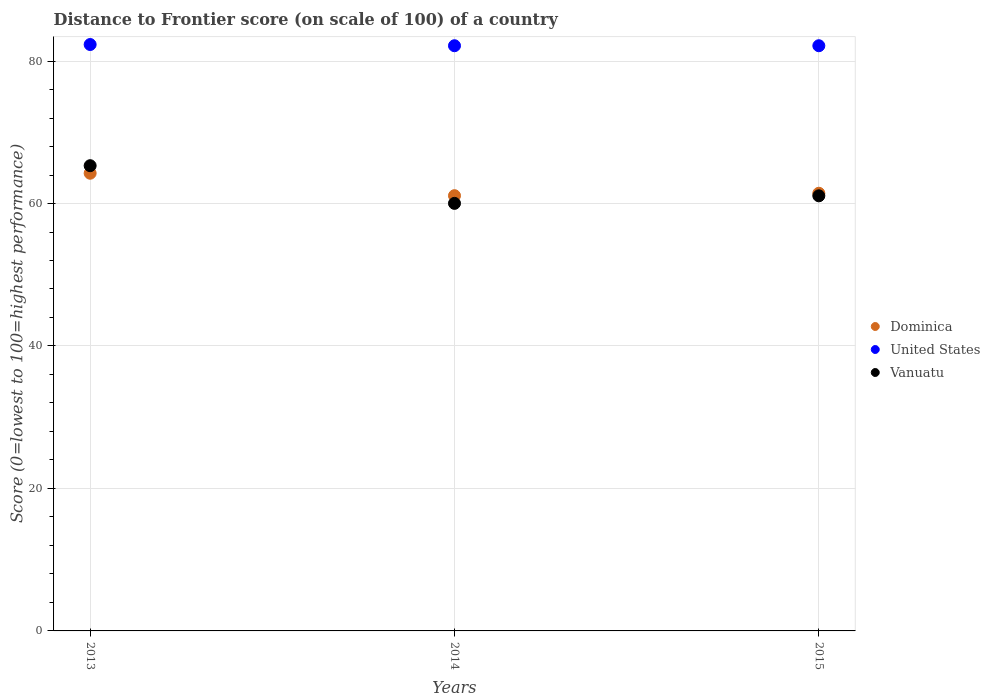How many different coloured dotlines are there?
Ensure brevity in your answer.  3. Is the number of dotlines equal to the number of legend labels?
Offer a very short reply. Yes. What is the distance to frontier score of in United States in 2015?
Provide a succinct answer. 82.15. Across all years, what is the maximum distance to frontier score of in Vanuatu?
Ensure brevity in your answer.  65.31. Across all years, what is the minimum distance to frontier score of in United States?
Offer a terse response. 82.15. In which year was the distance to frontier score of in United States minimum?
Give a very brief answer. 2014. What is the total distance to frontier score of in Vanuatu in the graph?
Provide a short and direct response. 186.41. What is the difference between the distance to frontier score of in Dominica in 2013 and that in 2014?
Your answer should be very brief. 3.15. What is the difference between the distance to frontier score of in United States in 2015 and the distance to frontier score of in Vanuatu in 2013?
Your answer should be very brief. 16.84. What is the average distance to frontier score of in Dominica per year?
Make the answer very short. 62.26. In the year 2013, what is the difference between the distance to frontier score of in United States and distance to frontier score of in Vanuatu?
Give a very brief answer. 17.01. What is the ratio of the distance to frontier score of in Vanuatu in 2013 to that in 2014?
Give a very brief answer. 1.09. Is the difference between the distance to frontier score of in United States in 2013 and 2014 greater than the difference between the distance to frontier score of in Vanuatu in 2013 and 2014?
Your response must be concise. No. What is the difference between the highest and the second highest distance to frontier score of in Dominica?
Your response must be concise. 2.81. What is the difference between the highest and the lowest distance to frontier score of in Vanuatu?
Provide a short and direct response. 5.29. Is the sum of the distance to frontier score of in Vanuatu in 2014 and 2015 greater than the maximum distance to frontier score of in United States across all years?
Your response must be concise. Yes. Does the distance to frontier score of in United States monotonically increase over the years?
Ensure brevity in your answer.  No. Is the distance to frontier score of in Dominica strictly less than the distance to frontier score of in Vanuatu over the years?
Your answer should be compact. No. How many dotlines are there?
Keep it short and to the point. 3. How many years are there in the graph?
Your answer should be very brief. 3. Does the graph contain grids?
Give a very brief answer. Yes. How are the legend labels stacked?
Provide a short and direct response. Vertical. What is the title of the graph?
Your response must be concise. Distance to Frontier score (on scale of 100) of a country. Does "Namibia" appear as one of the legend labels in the graph?
Your answer should be compact. No. What is the label or title of the X-axis?
Give a very brief answer. Years. What is the label or title of the Y-axis?
Your response must be concise. Score (0=lowest to 100=highest performance). What is the Score (0=lowest to 100=highest performance) of Dominica in 2013?
Ensure brevity in your answer.  64.25. What is the Score (0=lowest to 100=highest performance) in United States in 2013?
Give a very brief answer. 82.32. What is the Score (0=lowest to 100=highest performance) of Vanuatu in 2013?
Provide a succinct answer. 65.31. What is the Score (0=lowest to 100=highest performance) in Dominica in 2014?
Offer a terse response. 61.1. What is the Score (0=lowest to 100=highest performance) of United States in 2014?
Provide a short and direct response. 82.15. What is the Score (0=lowest to 100=highest performance) in Vanuatu in 2014?
Make the answer very short. 60.02. What is the Score (0=lowest to 100=highest performance) in Dominica in 2015?
Offer a terse response. 61.44. What is the Score (0=lowest to 100=highest performance) of United States in 2015?
Provide a short and direct response. 82.15. What is the Score (0=lowest to 100=highest performance) of Vanuatu in 2015?
Offer a very short reply. 61.08. Across all years, what is the maximum Score (0=lowest to 100=highest performance) of Dominica?
Make the answer very short. 64.25. Across all years, what is the maximum Score (0=lowest to 100=highest performance) of United States?
Provide a succinct answer. 82.32. Across all years, what is the maximum Score (0=lowest to 100=highest performance) in Vanuatu?
Make the answer very short. 65.31. Across all years, what is the minimum Score (0=lowest to 100=highest performance) in Dominica?
Your answer should be very brief. 61.1. Across all years, what is the minimum Score (0=lowest to 100=highest performance) of United States?
Offer a terse response. 82.15. Across all years, what is the minimum Score (0=lowest to 100=highest performance) of Vanuatu?
Keep it short and to the point. 60.02. What is the total Score (0=lowest to 100=highest performance) of Dominica in the graph?
Ensure brevity in your answer.  186.79. What is the total Score (0=lowest to 100=highest performance) of United States in the graph?
Your response must be concise. 246.62. What is the total Score (0=lowest to 100=highest performance) in Vanuatu in the graph?
Ensure brevity in your answer.  186.41. What is the difference between the Score (0=lowest to 100=highest performance) in Dominica in 2013 and that in 2014?
Offer a very short reply. 3.15. What is the difference between the Score (0=lowest to 100=highest performance) in United States in 2013 and that in 2014?
Make the answer very short. 0.17. What is the difference between the Score (0=lowest to 100=highest performance) in Vanuatu in 2013 and that in 2014?
Offer a very short reply. 5.29. What is the difference between the Score (0=lowest to 100=highest performance) in Dominica in 2013 and that in 2015?
Your answer should be compact. 2.81. What is the difference between the Score (0=lowest to 100=highest performance) of United States in 2013 and that in 2015?
Your response must be concise. 0.17. What is the difference between the Score (0=lowest to 100=highest performance) in Vanuatu in 2013 and that in 2015?
Your answer should be very brief. 4.23. What is the difference between the Score (0=lowest to 100=highest performance) in Dominica in 2014 and that in 2015?
Keep it short and to the point. -0.34. What is the difference between the Score (0=lowest to 100=highest performance) of Vanuatu in 2014 and that in 2015?
Offer a terse response. -1.06. What is the difference between the Score (0=lowest to 100=highest performance) of Dominica in 2013 and the Score (0=lowest to 100=highest performance) of United States in 2014?
Make the answer very short. -17.9. What is the difference between the Score (0=lowest to 100=highest performance) in Dominica in 2013 and the Score (0=lowest to 100=highest performance) in Vanuatu in 2014?
Provide a succinct answer. 4.23. What is the difference between the Score (0=lowest to 100=highest performance) of United States in 2013 and the Score (0=lowest to 100=highest performance) of Vanuatu in 2014?
Provide a short and direct response. 22.3. What is the difference between the Score (0=lowest to 100=highest performance) in Dominica in 2013 and the Score (0=lowest to 100=highest performance) in United States in 2015?
Provide a succinct answer. -17.9. What is the difference between the Score (0=lowest to 100=highest performance) of Dominica in 2013 and the Score (0=lowest to 100=highest performance) of Vanuatu in 2015?
Ensure brevity in your answer.  3.17. What is the difference between the Score (0=lowest to 100=highest performance) in United States in 2013 and the Score (0=lowest to 100=highest performance) in Vanuatu in 2015?
Your response must be concise. 21.24. What is the difference between the Score (0=lowest to 100=highest performance) in Dominica in 2014 and the Score (0=lowest to 100=highest performance) in United States in 2015?
Provide a succinct answer. -21.05. What is the difference between the Score (0=lowest to 100=highest performance) in Dominica in 2014 and the Score (0=lowest to 100=highest performance) in Vanuatu in 2015?
Offer a very short reply. 0.02. What is the difference between the Score (0=lowest to 100=highest performance) of United States in 2014 and the Score (0=lowest to 100=highest performance) of Vanuatu in 2015?
Your answer should be compact. 21.07. What is the average Score (0=lowest to 100=highest performance) of Dominica per year?
Offer a very short reply. 62.26. What is the average Score (0=lowest to 100=highest performance) of United States per year?
Offer a very short reply. 82.21. What is the average Score (0=lowest to 100=highest performance) in Vanuatu per year?
Offer a very short reply. 62.14. In the year 2013, what is the difference between the Score (0=lowest to 100=highest performance) in Dominica and Score (0=lowest to 100=highest performance) in United States?
Offer a terse response. -18.07. In the year 2013, what is the difference between the Score (0=lowest to 100=highest performance) in Dominica and Score (0=lowest to 100=highest performance) in Vanuatu?
Make the answer very short. -1.06. In the year 2013, what is the difference between the Score (0=lowest to 100=highest performance) in United States and Score (0=lowest to 100=highest performance) in Vanuatu?
Offer a terse response. 17.01. In the year 2014, what is the difference between the Score (0=lowest to 100=highest performance) of Dominica and Score (0=lowest to 100=highest performance) of United States?
Your answer should be compact. -21.05. In the year 2014, what is the difference between the Score (0=lowest to 100=highest performance) of United States and Score (0=lowest to 100=highest performance) of Vanuatu?
Your answer should be compact. 22.13. In the year 2015, what is the difference between the Score (0=lowest to 100=highest performance) of Dominica and Score (0=lowest to 100=highest performance) of United States?
Offer a very short reply. -20.71. In the year 2015, what is the difference between the Score (0=lowest to 100=highest performance) of Dominica and Score (0=lowest to 100=highest performance) of Vanuatu?
Your answer should be very brief. 0.36. In the year 2015, what is the difference between the Score (0=lowest to 100=highest performance) of United States and Score (0=lowest to 100=highest performance) of Vanuatu?
Your response must be concise. 21.07. What is the ratio of the Score (0=lowest to 100=highest performance) in Dominica in 2013 to that in 2014?
Provide a succinct answer. 1.05. What is the ratio of the Score (0=lowest to 100=highest performance) in Vanuatu in 2013 to that in 2014?
Your answer should be compact. 1.09. What is the ratio of the Score (0=lowest to 100=highest performance) of Dominica in 2013 to that in 2015?
Make the answer very short. 1.05. What is the ratio of the Score (0=lowest to 100=highest performance) in Vanuatu in 2013 to that in 2015?
Your answer should be very brief. 1.07. What is the ratio of the Score (0=lowest to 100=highest performance) in Dominica in 2014 to that in 2015?
Provide a succinct answer. 0.99. What is the ratio of the Score (0=lowest to 100=highest performance) in Vanuatu in 2014 to that in 2015?
Your response must be concise. 0.98. What is the difference between the highest and the second highest Score (0=lowest to 100=highest performance) in Dominica?
Your answer should be compact. 2.81. What is the difference between the highest and the second highest Score (0=lowest to 100=highest performance) in United States?
Offer a terse response. 0.17. What is the difference between the highest and the second highest Score (0=lowest to 100=highest performance) of Vanuatu?
Keep it short and to the point. 4.23. What is the difference between the highest and the lowest Score (0=lowest to 100=highest performance) in Dominica?
Offer a very short reply. 3.15. What is the difference between the highest and the lowest Score (0=lowest to 100=highest performance) of United States?
Offer a terse response. 0.17. What is the difference between the highest and the lowest Score (0=lowest to 100=highest performance) of Vanuatu?
Keep it short and to the point. 5.29. 